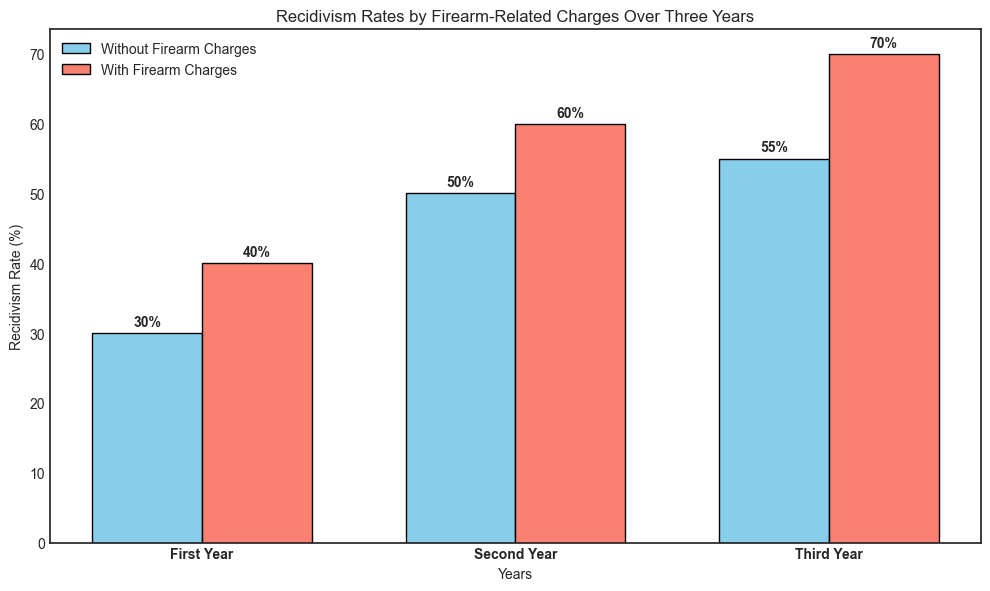Which group has the highest recidivism rate in the first year? From the plot, in the first year, the bar for "Offenders With Firearm Charges" is taller than the bar for "Offenders Without Firearm Charges". The height for offenders with firearm charges is 40% whereas for offenders without firearm charges it's 30%.
Answer: Offenders With Firearm Charges In the second year, how much higher is the recidivism rate for offenders with firearm charges compared to those without? Comparing the bars for the second year, the height of the bar for "Offenders With Firearm Charges" is 60% and for "Offenders Without Firearm Charges" it is 50%. The difference between these two rates is 60% - 50%.
Answer: 10% What is the average recidivism rate for offenders without firearm-related charges over the three years? The recidivism rates for offenders without firearm-related charges over three years are 30%, 50%, and 55%. The average is calculated as (30 + 50 + 55) / 3.
Answer: 45% In which year is the difference in recidivism rates between offenders with and without firearm charges the largest? We need to find the differences for each year: First year (40% - 30% = 10%), Second year (60% - 50% = 10%), Third year (70% - 55% = 15%). The largest difference is 15% in the third year.
Answer: Third year How does the recidivism rate of offenders with firearm charges change from the first year to the third year? For offenders with firearm charges, the recidivism rates for the first, second, and third years are 40%, 60%, and 70%, respectively. The rates increase over the years from 40% to 70%.
Answer: Increases What is the total recidivism rate for offenders with firearm charges over three years? Sum the recidivism rates for firearm offenders over the three years: 40% + 60% + 70%.
Answer: 170% Compare the recidivism rate trend over three years between offenders with and without firearm-related charges. Both groups show increasing trends: for offenders without firearm charges, the rates are 30%, 50%, and 55%; for offenders with firearm charges, they are 40%, 60%, and 70%. The increase is consistently higher for offenders with firearm charges.
Answer: Both increase, with firearm always higher By what percentage does the recidivism rate increase from the second year to the third year for offenders without firearm charges? The rates for offenders without firearm charges are 50% in the second year and 55% in the third year. The increase is calculated as (55% - 50%) / 50% * 100%.
Answer: 10% Do the recidivism rates for offenders with firearm charges ever decrease over the three years? Looking at the plot, the rates for offenders with firearm charges are 40%, 60%, and then 70% over the three years. There are no decreases.
Answer: No What is the total increase in recidivism rate for offenders without firearm-related charges from the first year to the third year? The rates for offenders without firearm charges are 30% in the first year and 55% in the third year. The increase is 55% - 30%.
Answer: 25% 